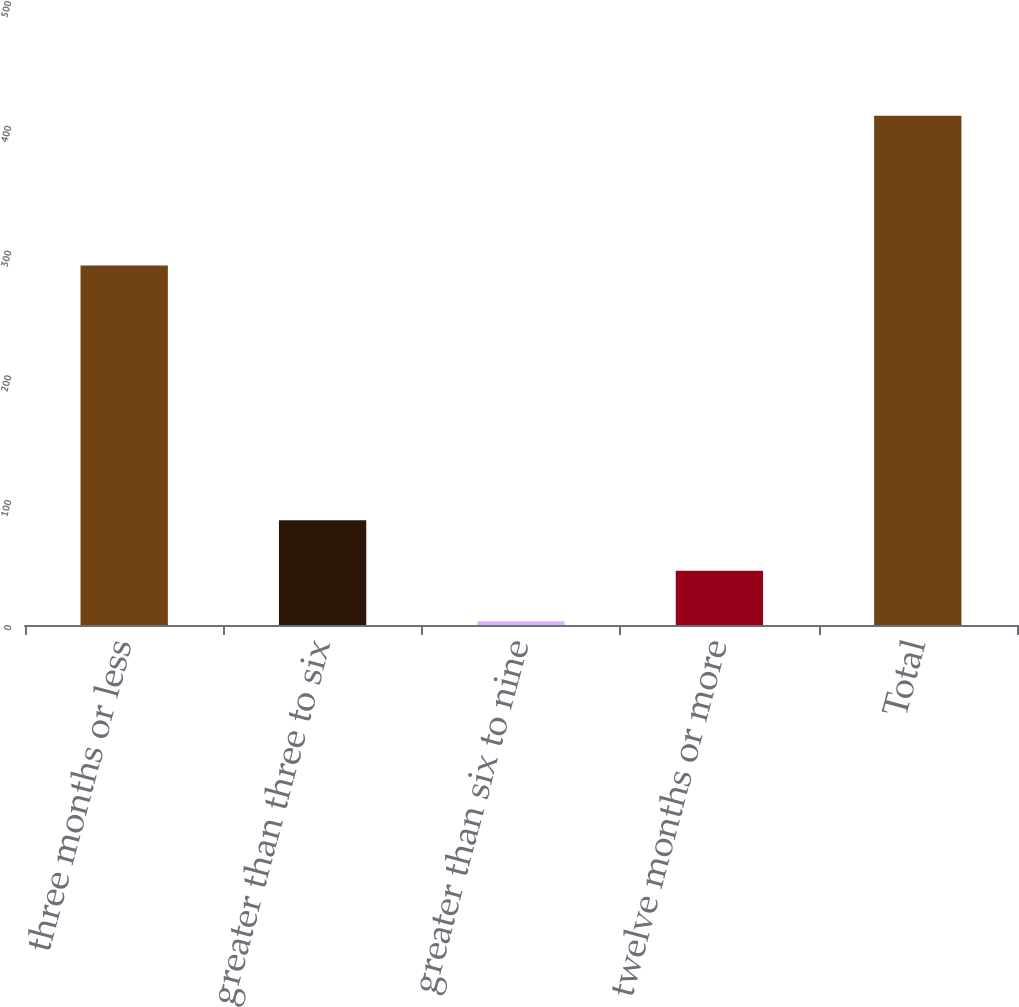Convert chart to OTSL. <chart><loc_0><loc_0><loc_500><loc_500><bar_chart><fcel>three months or less<fcel>greater than three to six<fcel>greater than six to nine<fcel>twelve months or more<fcel>Total<nl><fcel>288<fcel>84<fcel>3<fcel>43.5<fcel>408<nl></chart> 